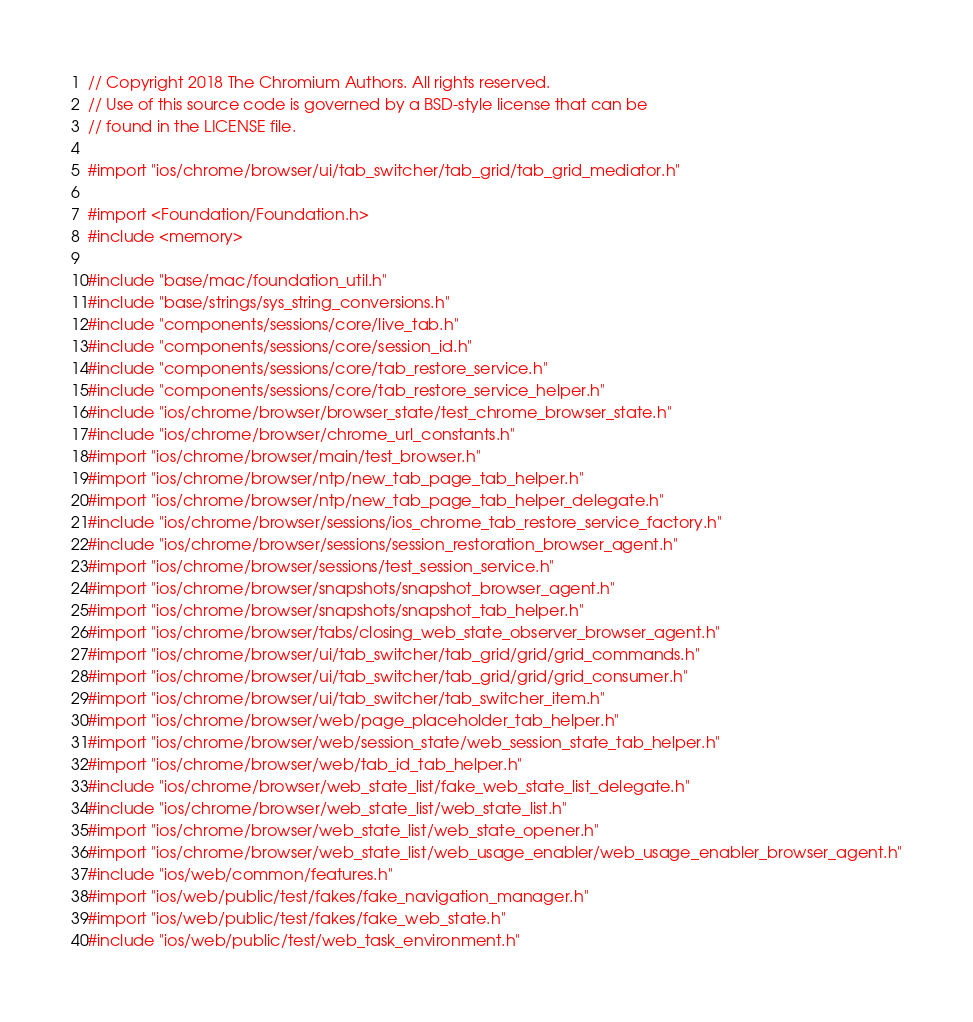<code> <loc_0><loc_0><loc_500><loc_500><_ObjectiveC_>// Copyright 2018 The Chromium Authors. All rights reserved.
// Use of this source code is governed by a BSD-style license that can be
// found in the LICENSE file.

#import "ios/chrome/browser/ui/tab_switcher/tab_grid/tab_grid_mediator.h"

#import <Foundation/Foundation.h>
#include <memory>

#include "base/mac/foundation_util.h"
#include "base/strings/sys_string_conversions.h"
#include "components/sessions/core/live_tab.h"
#include "components/sessions/core/session_id.h"
#include "components/sessions/core/tab_restore_service.h"
#include "components/sessions/core/tab_restore_service_helper.h"
#include "ios/chrome/browser/browser_state/test_chrome_browser_state.h"
#include "ios/chrome/browser/chrome_url_constants.h"
#import "ios/chrome/browser/main/test_browser.h"
#import "ios/chrome/browser/ntp/new_tab_page_tab_helper.h"
#import "ios/chrome/browser/ntp/new_tab_page_tab_helper_delegate.h"
#include "ios/chrome/browser/sessions/ios_chrome_tab_restore_service_factory.h"
#include "ios/chrome/browser/sessions/session_restoration_browser_agent.h"
#import "ios/chrome/browser/sessions/test_session_service.h"
#import "ios/chrome/browser/snapshots/snapshot_browser_agent.h"
#import "ios/chrome/browser/snapshots/snapshot_tab_helper.h"
#import "ios/chrome/browser/tabs/closing_web_state_observer_browser_agent.h"
#import "ios/chrome/browser/ui/tab_switcher/tab_grid/grid/grid_commands.h"
#import "ios/chrome/browser/ui/tab_switcher/tab_grid/grid/grid_consumer.h"
#import "ios/chrome/browser/ui/tab_switcher/tab_switcher_item.h"
#import "ios/chrome/browser/web/page_placeholder_tab_helper.h"
#import "ios/chrome/browser/web/session_state/web_session_state_tab_helper.h"
#import "ios/chrome/browser/web/tab_id_tab_helper.h"
#include "ios/chrome/browser/web_state_list/fake_web_state_list_delegate.h"
#include "ios/chrome/browser/web_state_list/web_state_list.h"
#import "ios/chrome/browser/web_state_list/web_state_opener.h"
#import "ios/chrome/browser/web_state_list/web_usage_enabler/web_usage_enabler_browser_agent.h"
#include "ios/web/common/features.h"
#import "ios/web/public/test/fakes/fake_navigation_manager.h"
#import "ios/web/public/test/fakes/fake_web_state.h"
#include "ios/web/public/test/web_task_environment.h"</code> 